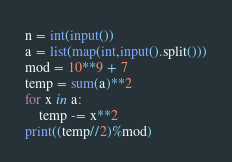Convert code to text. <code><loc_0><loc_0><loc_500><loc_500><_Python_>n = int(input())
a = list(map(int,input().split()))
mod = 10**9 + 7
temp = sum(a)**2
for x in a:
	temp -= x**2
print((temp//2)%mod)</code> 